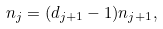Convert formula to latex. <formula><loc_0><loc_0><loc_500><loc_500>n _ { j } = ( d _ { j + 1 } - 1 ) n _ { j + 1 } ,</formula> 